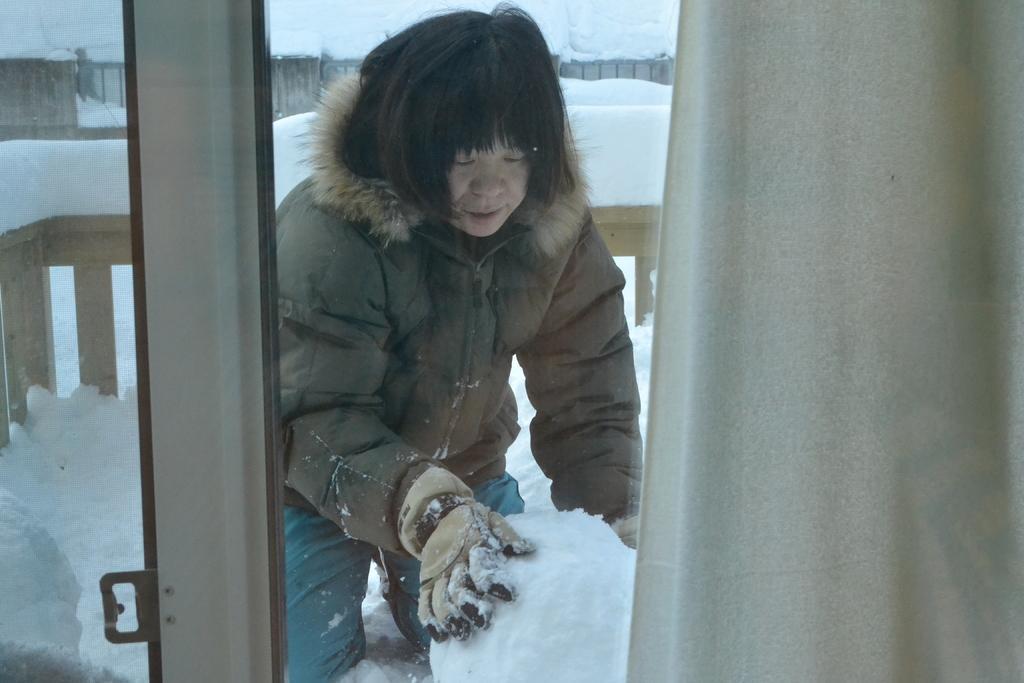Can you describe this image briefly? In this image I can see a window and a curtain. Through the window I can see a person making a snow ball and there is snow and fences at the back. 